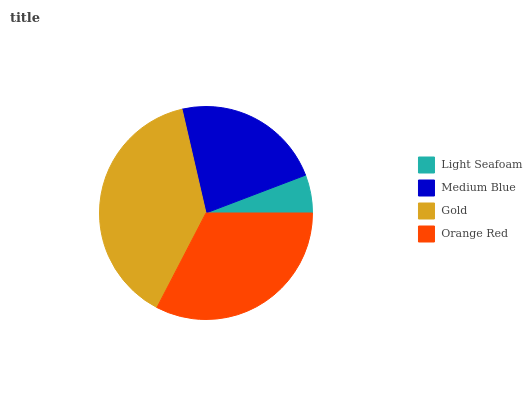Is Light Seafoam the minimum?
Answer yes or no. Yes. Is Gold the maximum?
Answer yes or no. Yes. Is Medium Blue the minimum?
Answer yes or no. No. Is Medium Blue the maximum?
Answer yes or no. No. Is Medium Blue greater than Light Seafoam?
Answer yes or no. Yes. Is Light Seafoam less than Medium Blue?
Answer yes or no. Yes. Is Light Seafoam greater than Medium Blue?
Answer yes or no. No. Is Medium Blue less than Light Seafoam?
Answer yes or no. No. Is Orange Red the high median?
Answer yes or no. Yes. Is Medium Blue the low median?
Answer yes or no. Yes. Is Gold the high median?
Answer yes or no. No. Is Light Seafoam the low median?
Answer yes or no. No. 